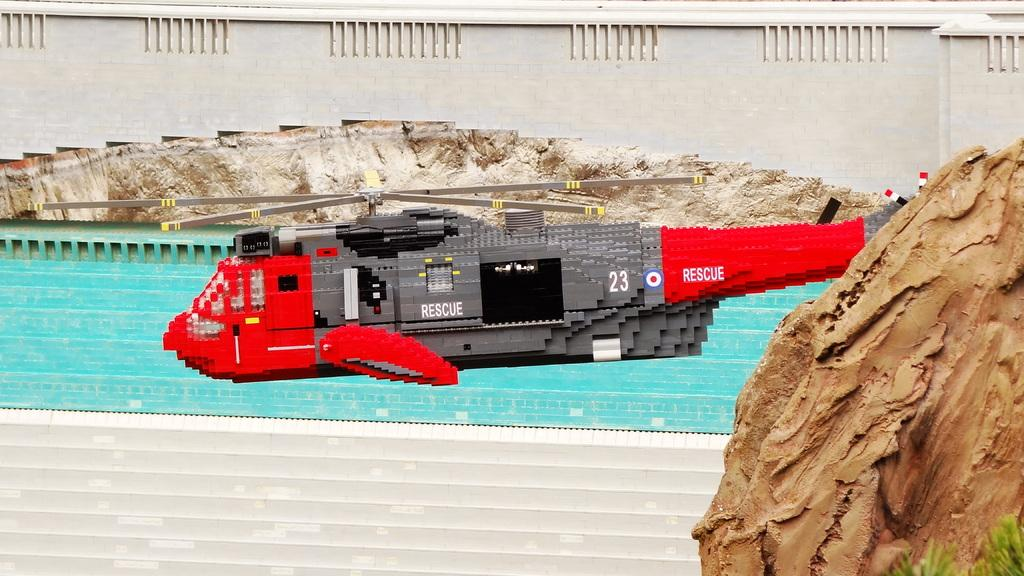What type of toy is in the picture? There is a toy helicopter in the picture. What natural element can be seen in the picture? There is a rock in the picture. What man-made structure is in the picture? There is a bridge in the picture. What is the water in the picture doing? The water is visible in the picture. What type of adjustment can be seen on the toy helicopter in the picture? There is no specific adjustment mentioned or visible on the toy helicopter in the image. Who is the partner of the person in the picture? There is no person present in the image, so there is no partner to identify. 